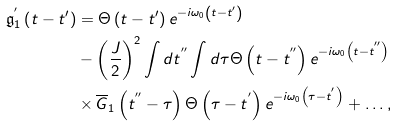Convert formula to latex. <formula><loc_0><loc_0><loc_500><loc_500>\mathfrak { g } _ { 1 } ^ { ^ { \prime } } \left ( t - t ^ { \prime } \right ) & = \Theta \left ( t - t ^ { \prime } \right ) e ^ { - i \omega _ { 0 } \left ( t - t ^ { \prime } \right ) } \\ & - \left ( \frac { J } { 2 } \right ) ^ { 2 } \int d t ^ { ^ { \prime \prime } } \int d \tau \Theta \left ( t - t ^ { ^ { \prime \prime } } \right ) e ^ { - i \omega _ { 0 } \left ( t - t ^ { ^ { \prime \prime } } \right ) } \\ & \times \overline { G } _ { 1 } \left ( t ^ { ^ { \prime \prime } } - \tau \right ) \Theta \left ( \tau - t ^ { ^ { \prime } } \right ) e ^ { - i \omega _ { 0 } \left ( \tau - t ^ { ^ { \prime } } \right ) } + \dots ,</formula> 